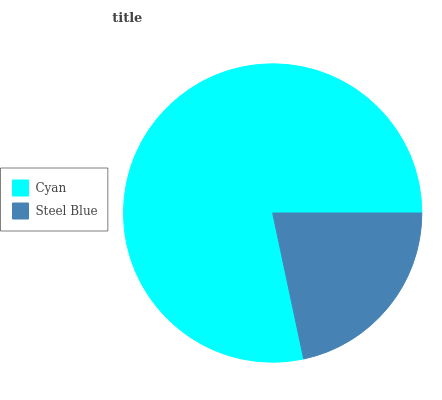Is Steel Blue the minimum?
Answer yes or no. Yes. Is Cyan the maximum?
Answer yes or no. Yes. Is Steel Blue the maximum?
Answer yes or no. No. Is Cyan greater than Steel Blue?
Answer yes or no. Yes. Is Steel Blue less than Cyan?
Answer yes or no. Yes. Is Steel Blue greater than Cyan?
Answer yes or no. No. Is Cyan less than Steel Blue?
Answer yes or no. No. Is Cyan the high median?
Answer yes or no. Yes. Is Steel Blue the low median?
Answer yes or no. Yes. Is Steel Blue the high median?
Answer yes or no. No. Is Cyan the low median?
Answer yes or no. No. 